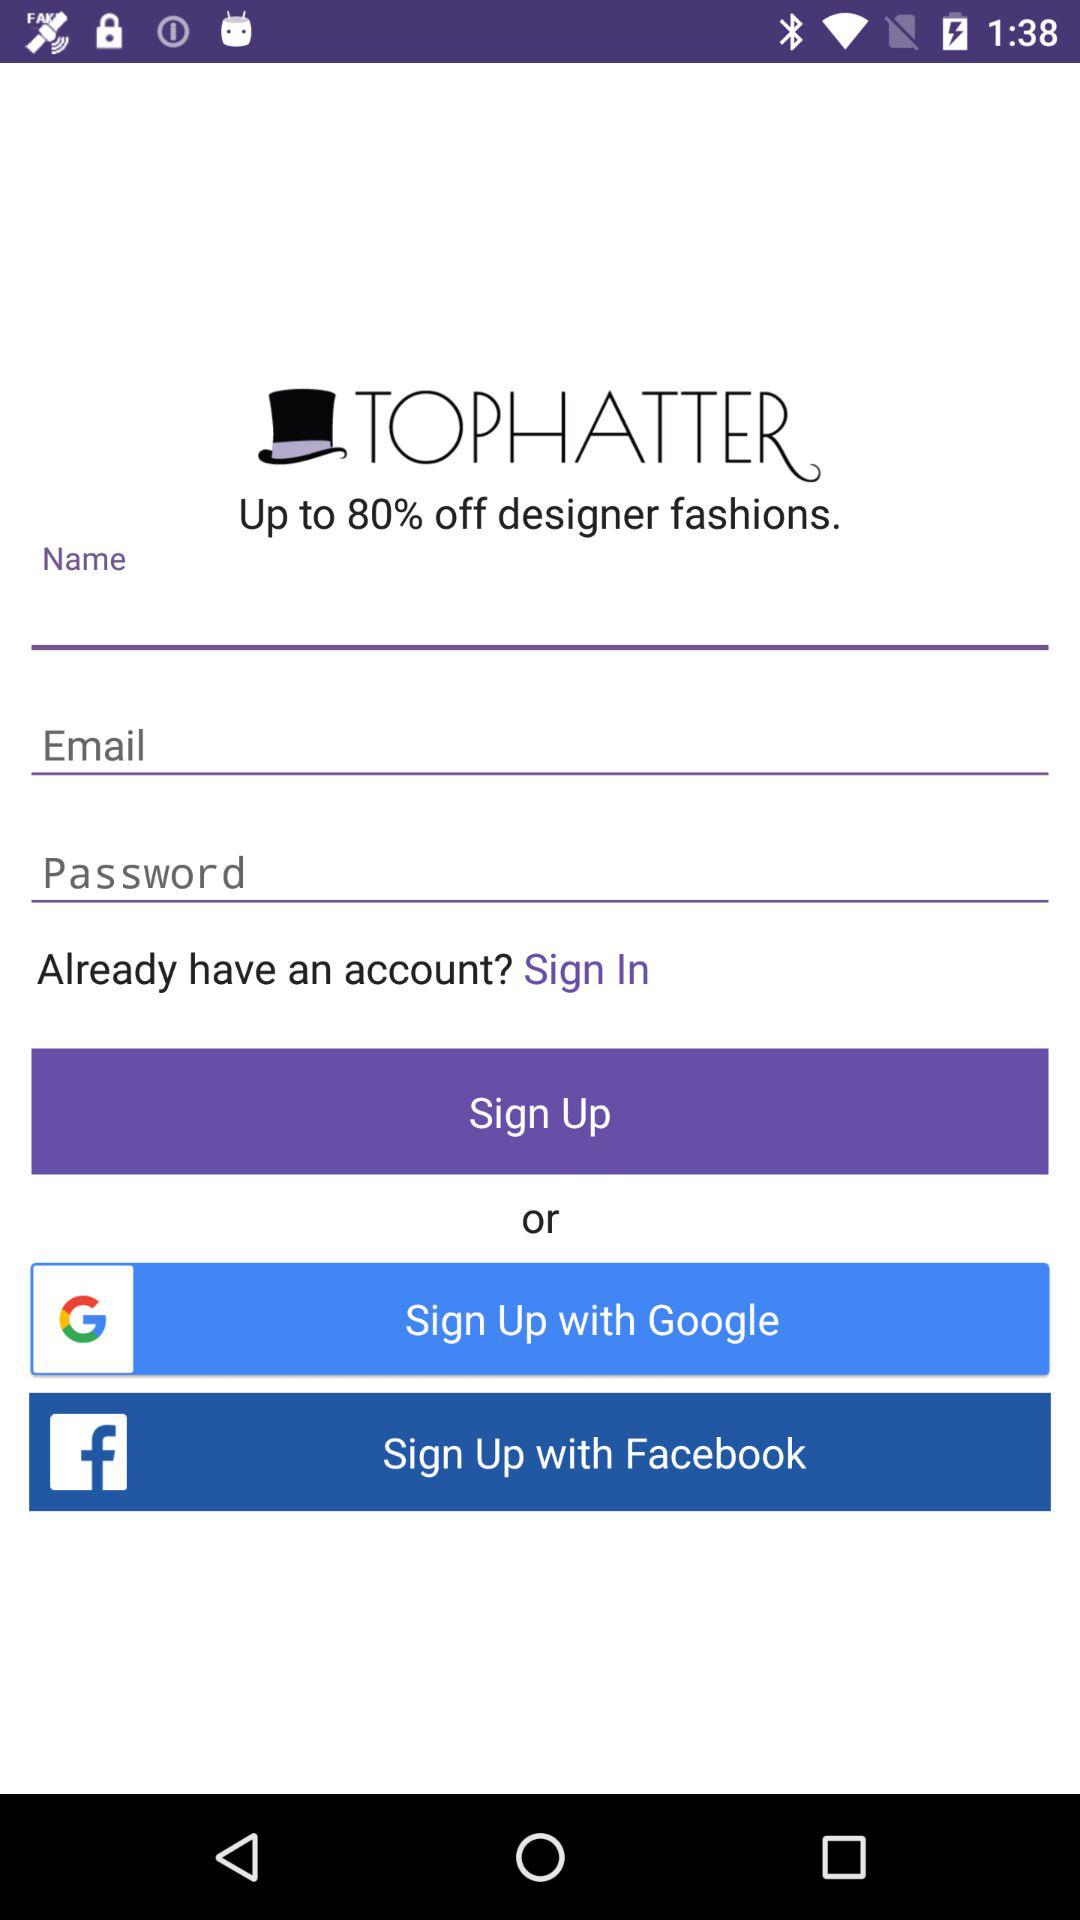What is the application name? The application name is "TOPHATTER". 